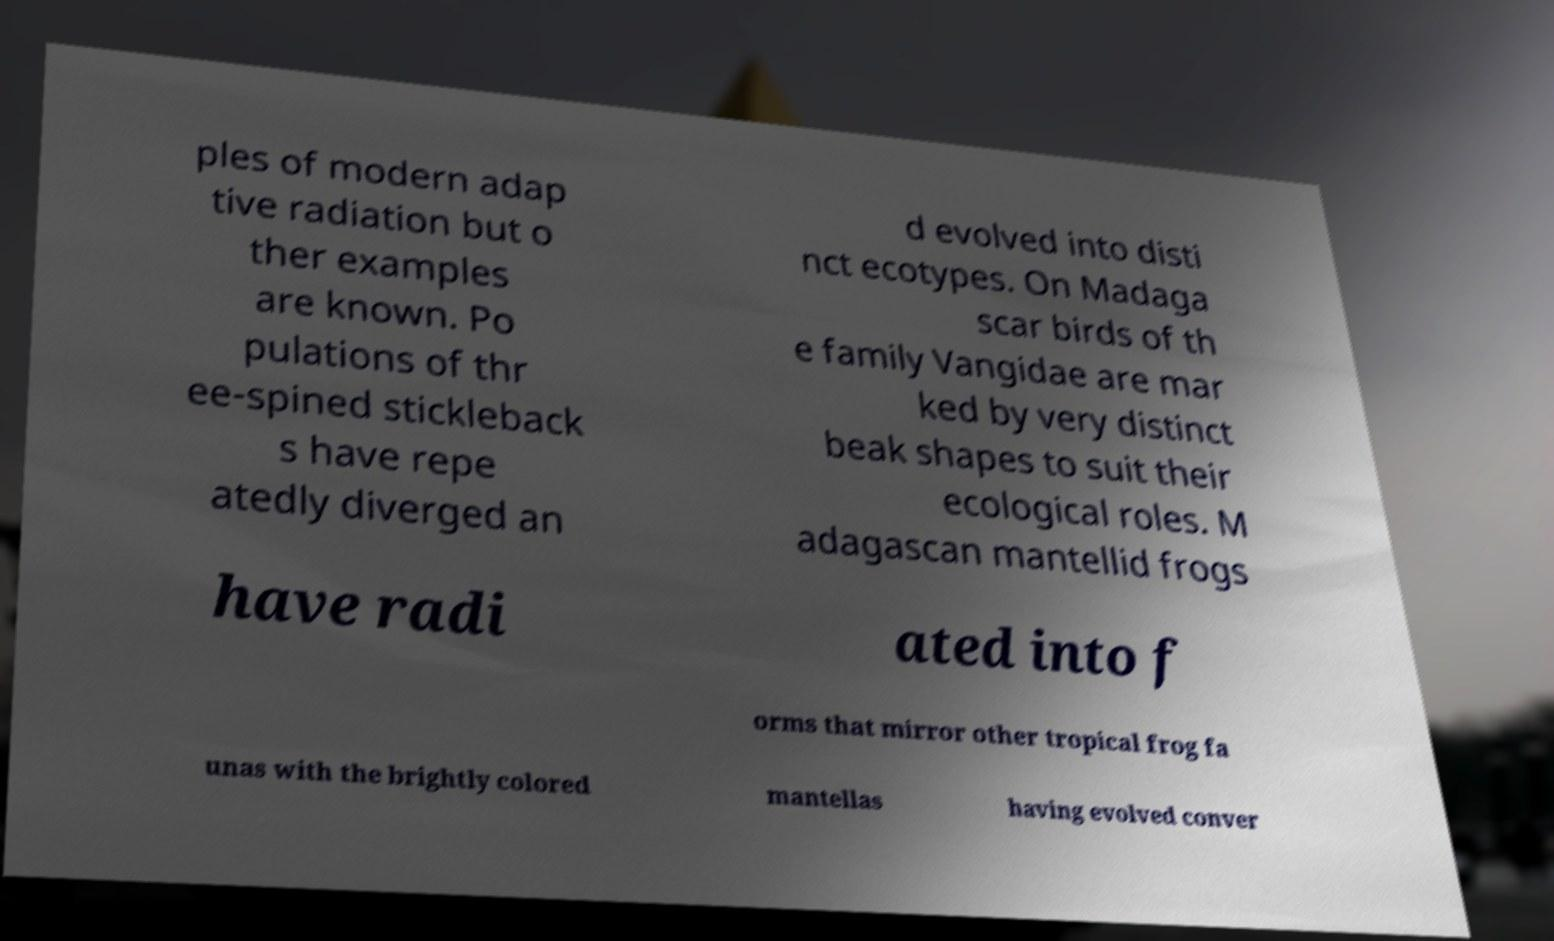There's text embedded in this image that I need extracted. Can you transcribe it verbatim? ples of modern adap tive radiation but o ther examples are known. Po pulations of thr ee-spined stickleback s have repe atedly diverged an d evolved into disti nct ecotypes. On Madaga scar birds of th e family Vangidae are mar ked by very distinct beak shapes to suit their ecological roles. M adagascan mantellid frogs have radi ated into f orms that mirror other tropical frog fa unas with the brightly colored mantellas having evolved conver 